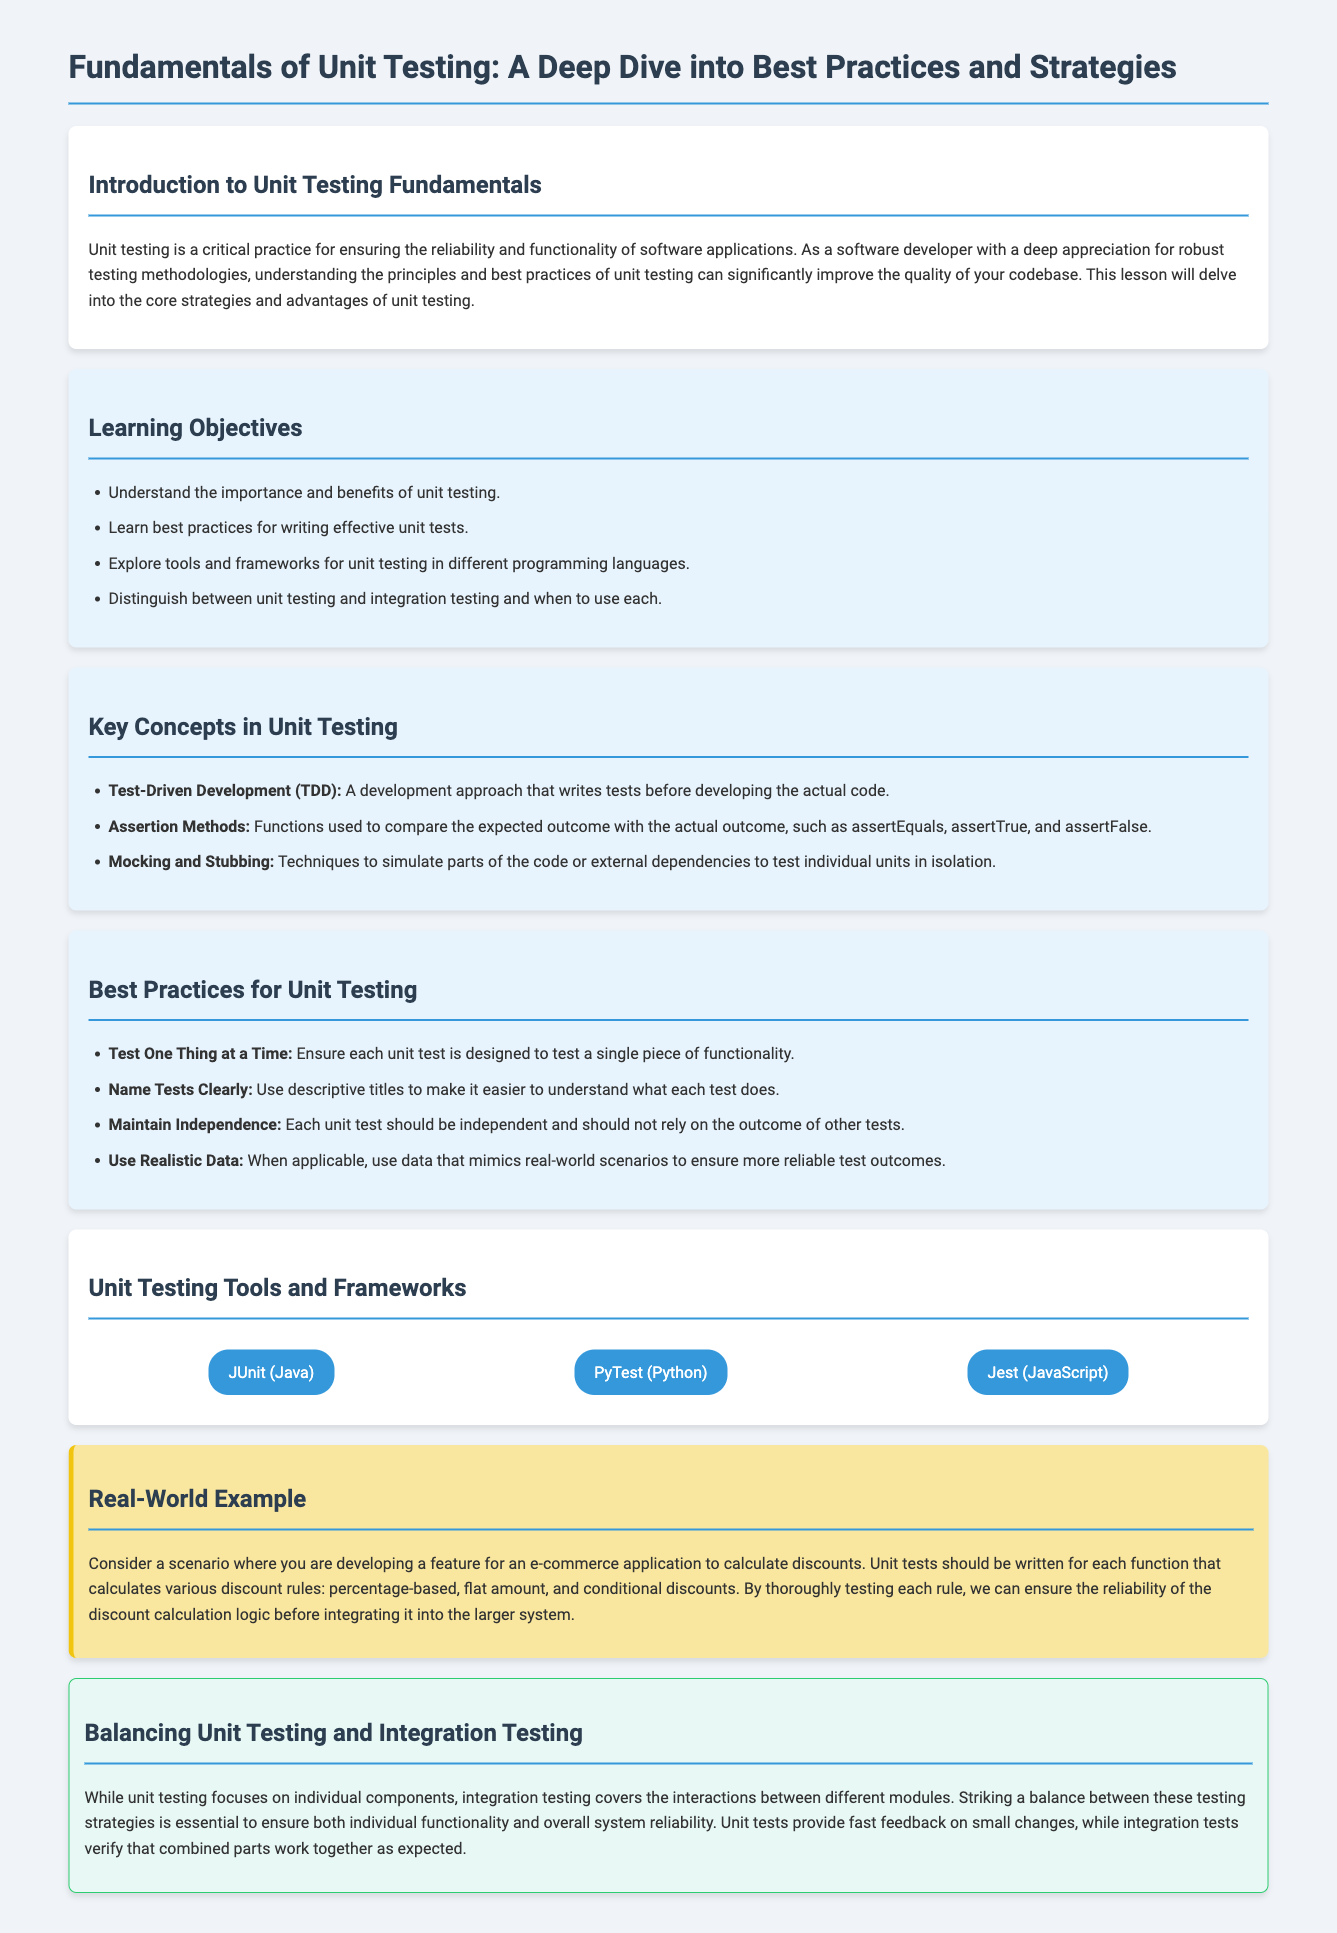What is the title of the lesson? The title of the lesson is indicated at the top of the document.
Answer: Fundamentals of Unit Testing: A Deep Dive into Best Practices and Strategies What is one benefit of unit testing mentioned? One benefit of unit testing is highlighted in the learning objectives section.
Answer: Importance and benefits of unit testing What does TDD stand for? TDD is a key concept in unit testing explained in the document.
Answer: Test-Driven Development What should unit tests ensure according to best practices? Best practices mention that unit tests should be designed in a specific way to ensure testing effectiveness.
Answer: Test One Thing at a Time Which framework is used for unit testing in Java? The document lists various tools for unit testing, including one specifically for Java.
Answer: JUnit What is the focus of integration testing in relation to unit testing? The balance section discusses the purpose of integration testing compared to unit testing.
Answer: Interactions between different modules How many specific unit testing tools are mentioned? The document provides a clear list of unit testing tools used for different programming languages.
Answer: Three What is the color of the background for best practices section? The color coding in the document helps distinguish different sections, including the one for best practices.
Answer: Light blue What do assertion methods do? The document defines the function of assertion methods as a key concept in unit testing.
Answer: Compare expected and actual outcome 